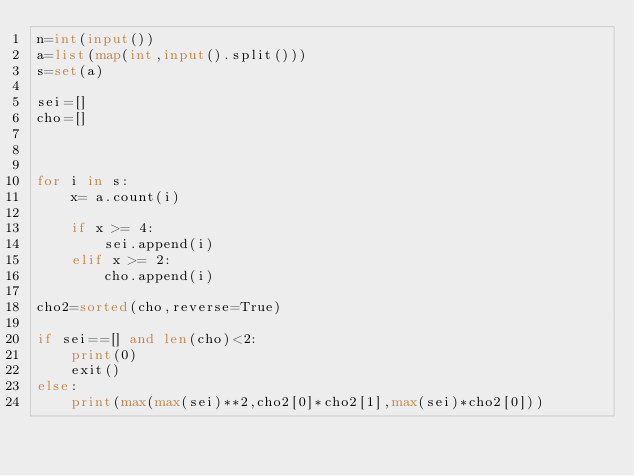Convert code to text. <code><loc_0><loc_0><loc_500><loc_500><_Python_>n=int(input())
a=list(map(int,input().split()))
s=set(a)

sei=[]
cho=[]



for i in s:
    x= a.count(i)
    
    if x >= 4:
        sei.append(i)
    elif x >= 2:
        cho.append(i)

cho2=sorted(cho,reverse=True)
        
if sei==[] and len(cho)<2:        
    print(0)
    exit()
else:
    print(max(max(sei)**2,cho2[0]*cho2[1],max(sei)*cho2[0]))

</code> 